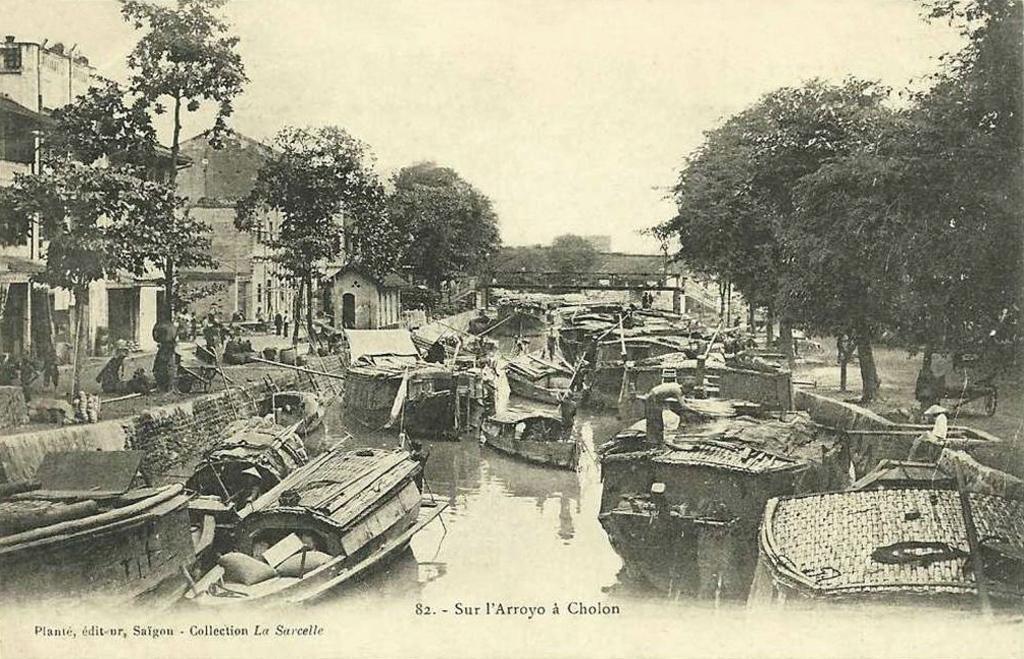Describe this image in one or two sentences. This is a picture of a poster. In this picture we can see buildings, trees, water, boards people and objects. At the bottom portion of the picture there is something written. 